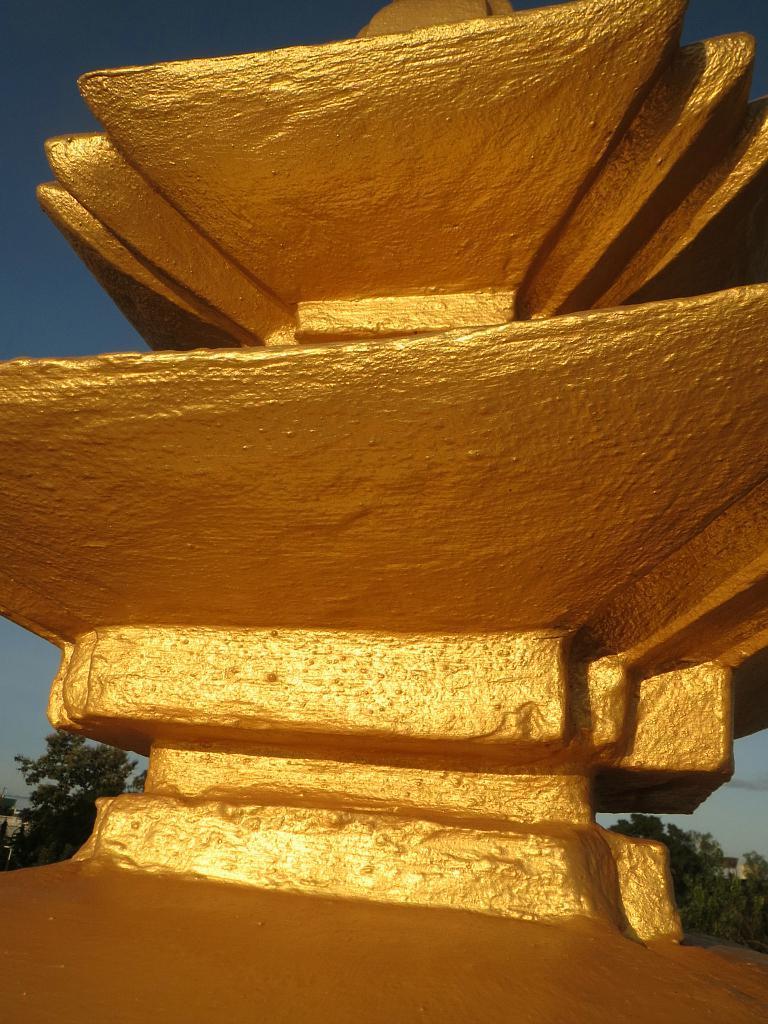How would you summarize this image in a sentence or two? In the foreground of this image, there is a golden structure and in the background, there are trees and the sky. 